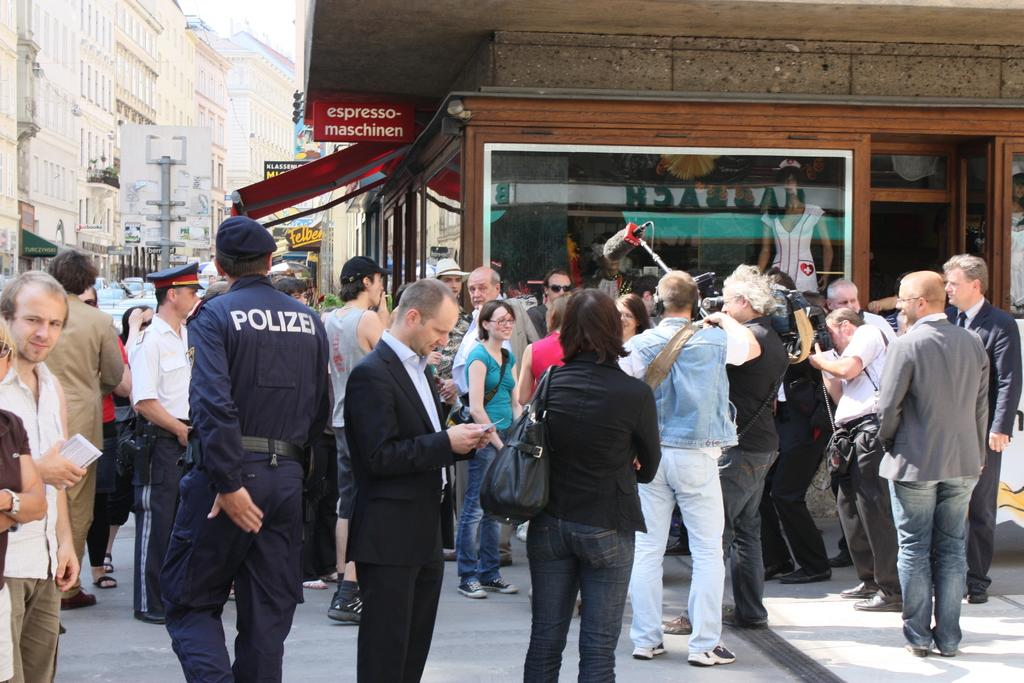How many people are in the image? There are people in the image, but the exact number is not specified. What are some people holding in the image? Some people are holding something, but the specific objects are not mentioned. What type of structures can be seen in the image? There are buildings in the image. What is attached to the buildings? There are boards on the buildings. What else can be seen in the image? There are poles in the image. What type of nerve is being studied by the people in the image? There is no mention of any nerves or scientific research in the image. The image primarily features people, buildings, boards, and poles. 